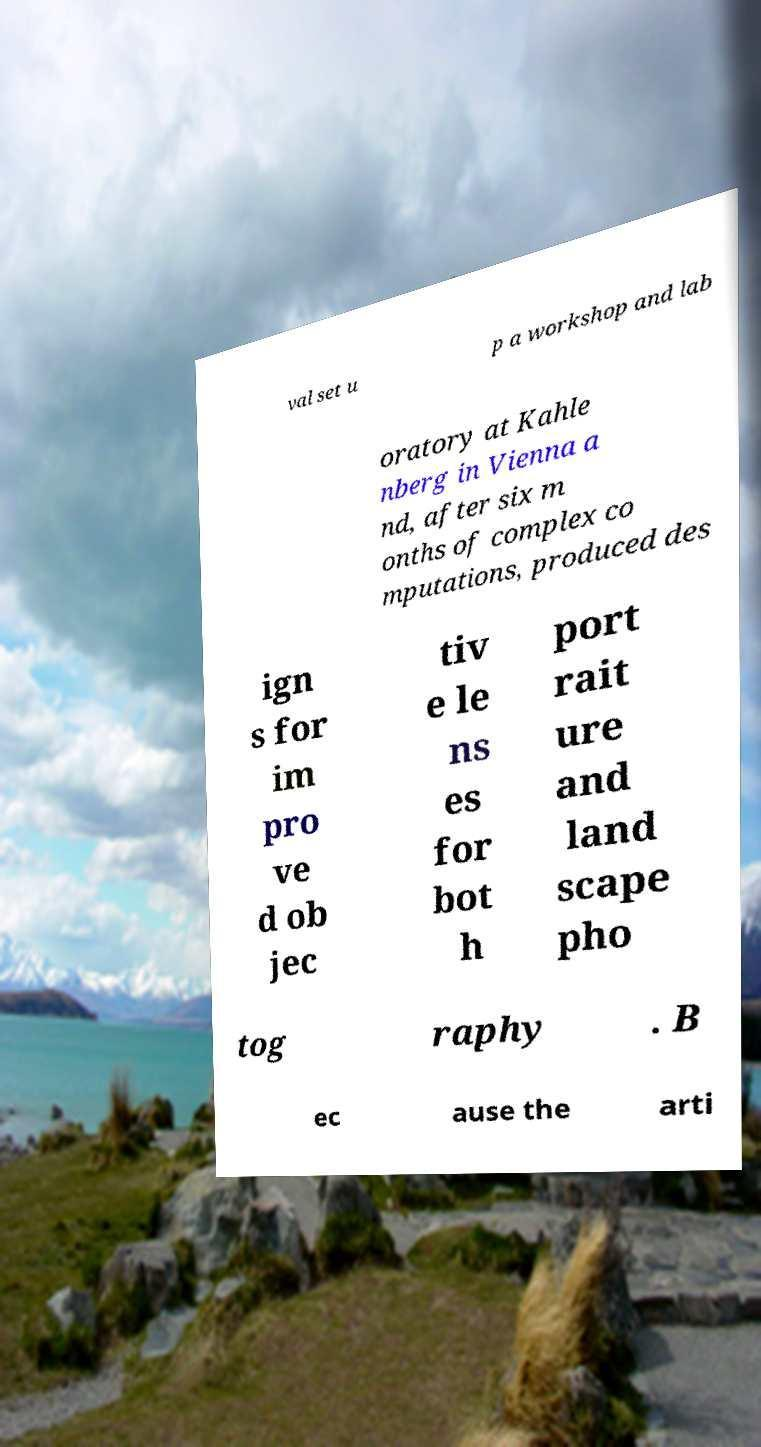Please identify and transcribe the text found in this image. val set u p a workshop and lab oratory at Kahle nberg in Vienna a nd, after six m onths of complex co mputations, produced des ign s for im pro ve d ob jec tiv e le ns es for bot h port rait ure and land scape pho tog raphy . B ec ause the arti 